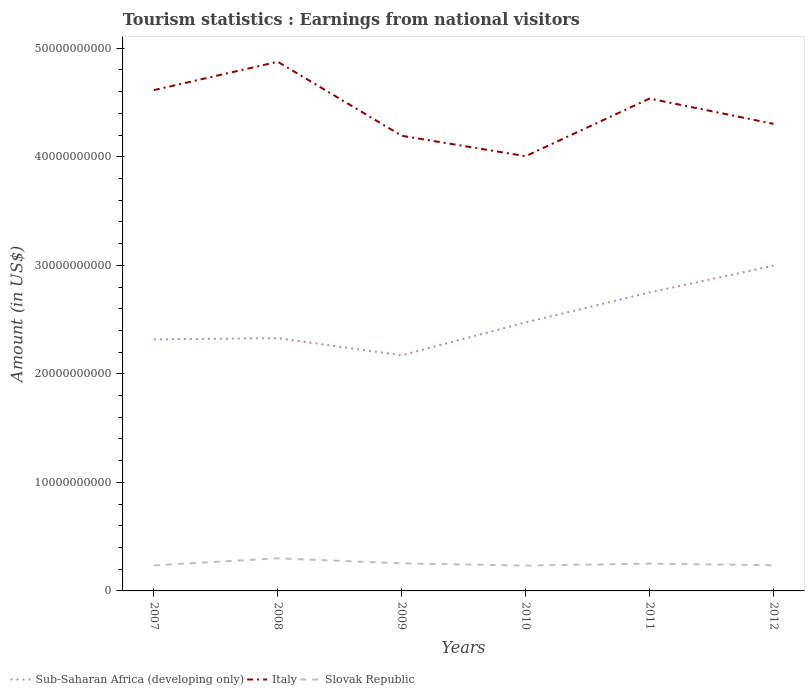Across all years, what is the maximum earnings from national visitors in Sub-Saharan Africa (developing only)?
Make the answer very short. 2.17e+1. What is the total earnings from national visitors in Italy in the graph?
Your response must be concise. -5.31e+09. What is the difference between the highest and the second highest earnings from national visitors in Italy?
Make the answer very short. 8.70e+09. How many lines are there?
Provide a succinct answer. 3. What is the difference between two consecutive major ticks on the Y-axis?
Ensure brevity in your answer.  1.00e+1. Does the graph contain grids?
Your answer should be compact. No. What is the title of the graph?
Your response must be concise. Tourism statistics : Earnings from national visitors. What is the label or title of the X-axis?
Keep it short and to the point. Years. What is the label or title of the Y-axis?
Your answer should be very brief. Amount (in US$). What is the Amount (in US$) in Sub-Saharan Africa (developing only) in 2007?
Make the answer very short. 2.32e+1. What is the Amount (in US$) of Italy in 2007?
Your response must be concise. 4.61e+1. What is the Amount (in US$) in Slovak Republic in 2007?
Offer a terse response. 2.35e+09. What is the Amount (in US$) of Sub-Saharan Africa (developing only) in 2008?
Make the answer very short. 2.33e+1. What is the Amount (in US$) in Italy in 2008?
Give a very brief answer. 4.88e+1. What is the Amount (in US$) of Slovak Republic in 2008?
Your response must be concise. 3.00e+09. What is the Amount (in US$) in Sub-Saharan Africa (developing only) in 2009?
Your response must be concise. 2.17e+1. What is the Amount (in US$) of Italy in 2009?
Your answer should be compact. 4.19e+1. What is the Amount (in US$) of Slovak Republic in 2009?
Keep it short and to the point. 2.54e+09. What is the Amount (in US$) of Sub-Saharan Africa (developing only) in 2010?
Offer a terse response. 2.47e+1. What is the Amount (in US$) in Italy in 2010?
Keep it short and to the point. 4.01e+1. What is the Amount (in US$) in Slovak Republic in 2010?
Provide a succinct answer. 2.34e+09. What is the Amount (in US$) in Sub-Saharan Africa (developing only) in 2011?
Provide a short and direct response. 2.75e+1. What is the Amount (in US$) of Italy in 2011?
Keep it short and to the point. 4.54e+1. What is the Amount (in US$) of Slovak Republic in 2011?
Ensure brevity in your answer.  2.51e+09. What is the Amount (in US$) in Sub-Saharan Africa (developing only) in 2012?
Your answer should be very brief. 3.00e+1. What is the Amount (in US$) of Italy in 2012?
Offer a terse response. 4.30e+1. What is the Amount (in US$) in Slovak Republic in 2012?
Provide a succinct answer. 2.36e+09. Across all years, what is the maximum Amount (in US$) in Sub-Saharan Africa (developing only)?
Offer a terse response. 3.00e+1. Across all years, what is the maximum Amount (in US$) of Italy?
Offer a very short reply. 4.88e+1. Across all years, what is the maximum Amount (in US$) in Slovak Republic?
Give a very brief answer. 3.00e+09. Across all years, what is the minimum Amount (in US$) in Sub-Saharan Africa (developing only)?
Give a very brief answer. 2.17e+1. Across all years, what is the minimum Amount (in US$) in Italy?
Offer a terse response. 4.01e+1. Across all years, what is the minimum Amount (in US$) in Slovak Republic?
Your answer should be very brief. 2.34e+09. What is the total Amount (in US$) of Sub-Saharan Africa (developing only) in the graph?
Your answer should be very brief. 1.50e+11. What is the total Amount (in US$) in Italy in the graph?
Give a very brief answer. 2.65e+11. What is the total Amount (in US$) in Slovak Republic in the graph?
Your answer should be compact. 1.51e+1. What is the difference between the Amount (in US$) of Sub-Saharan Africa (developing only) in 2007 and that in 2008?
Make the answer very short. -1.09e+08. What is the difference between the Amount (in US$) of Italy in 2007 and that in 2008?
Your answer should be compact. -2.61e+09. What is the difference between the Amount (in US$) of Slovak Republic in 2007 and that in 2008?
Make the answer very short. -6.52e+08. What is the difference between the Amount (in US$) in Sub-Saharan Africa (developing only) in 2007 and that in 2009?
Offer a terse response. 1.46e+09. What is the difference between the Amount (in US$) of Italy in 2007 and that in 2009?
Provide a succinct answer. 4.21e+09. What is the difference between the Amount (in US$) in Slovak Republic in 2007 and that in 2009?
Offer a very short reply. -1.87e+08. What is the difference between the Amount (in US$) in Sub-Saharan Africa (developing only) in 2007 and that in 2010?
Offer a very short reply. -1.56e+09. What is the difference between the Amount (in US$) of Italy in 2007 and that in 2010?
Give a very brief answer. 6.09e+09. What is the difference between the Amount (in US$) in Slovak Republic in 2007 and that in 2010?
Make the answer very short. 1.70e+07. What is the difference between the Amount (in US$) of Sub-Saharan Africa (developing only) in 2007 and that in 2011?
Keep it short and to the point. -4.32e+09. What is the difference between the Amount (in US$) in Italy in 2007 and that in 2011?
Provide a succinct answer. 7.76e+08. What is the difference between the Amount (in US$) in Slovak Republic in 2007 and that in 2011?
Give a very brief answer. -1.62e+08. What is the difference between the Amount (in US$) of Sub-Saharan Africa (developing only) in 2007 and that in 2012?
Offer a very short reply. -6.78e+09. What is the difference between the Amount (in US$) of Italy in 2007 and that in 2012?
Give a very brief answer. 3.11e+09. What is the difference between the Amount (in US$) of Slovak Republic in 2007 and that in 2012?
Make the answer very short. -1.30e+07. What is the difference between the Amount (in US$) of Sub-Saharan Africa (developing only) in 2008 and that in 2009?
Your answer should be very brief. 1.57e+09. What is the difference between the Amount (in US$) of Italy in 2008 and that in 2009?
Offer a very short reply. 6.82e+09. What is the difference between the Amount (in US$) of Slovak Republic in 2008 and that in 2009?
Offer a very short reply. 4.65e+08. What is the difference between the Amount (in US$) of Sub-Saharan Africa (developing only) in 2008 and that in 2010?
Provide a short and direct response. -1.45e+09. What is the difference between the Amount (in US$) in Italy in 2008 and that in 2010?
Your answer should be very brief. 8.70e+09. What is the difference between the Amount (in US$) in Slovak Republic in 2008 and that in 2010?
Offer a terse response. 6.69e+08. What is the difference between the Amount (in US$) in Sub-Saharan Africa (developing only) in 2008 and that in 2011?
Give a very brief answer. -4.21e+09. What is the difference between the Amount (in US$) in Italy in 2008 and that in 2011?
Provide a succinct answer. 3.39e+09. What is the difference between the Amount (in US$) of Slovak Republic in 2008 and that in 2011?
Offer a very short reply. 4.90e+08. What is the difference between the Amount (in US$) in Sub-Saharan Africa (developing only) in 2008 and that in 2012?
Your response must be concise. -6.67e+09. What is the difference between the Amount (in US$) of Italy in 2008 and that in 2012?
Provide a succinct answer. 5.72e+09. What is the difference between the Amount (in US$) of Slovak Republic in 2008 and that in 2012?
Provide a succinct answer. 6.39e+08. What is the difference between the Amount (in US$) of Sub-Saharan Africa (developing only) in 2009 and that in 2010?
Give a very brief answer. -3.03e+09. What is the difference between the Amount (in US$) in Italy in 2009 and that in 2010?
Keep it short and to the point. 1.88e+09. What is the difference between the Amount (in US$) of Slovak Republic in 2009 and that in 2010?
Make the answer very short. 2.04e+08. What is the difference between the Amount (in US$) in Sub-Saharan Africa (developing only) in 2009 and that in 2011?
Keep it short and to the point. -5.79e+09. What is the difference between the Amount (in US$) in Italy in 2009 and that in 2011?
Your answer should be compact. -3.43e+09. What is the difference between the Amount (in US$) of Slovak Republic in 2009 and that in 2011?
Make the answer very short. 2.50e+07. What is the difference between the Amount (in US$) of Sub-Saharan Africa (developing only) in 2009 and that in 2012?
Provide a succinct answer. -8.25e+09. What is the difference between the Amount (in US$) of Italy in 2009 and that in 2012?
Your answer should be very brief. -1.10e+09. What is the difference between the Amount (in US$) of Slovak Republic in 2009 and that in 2012?
Provide a short and direct response. 1.74e+08. What is the difference between the Amount (in US$) of Sub-Saharan Africa (developing only) in 2010 and that in 2011?
Your answer should be compact. -2.76e+09. What is the difference between the Amount (in US$) in Italy in 2010 and that in 2011?
Provide a short and direct response. -5.31e+09. What is the difference between the Amount (in US$) of Slovak Republic in 2010 and that in 2011?
Your answer should be very brief. -1.79e+08. What is the difference between the Amount (in US$) in Sub-Saharan Africa (developing only) in 2010 and that in 2012?
Offer a very short reply. -5.22e+09. What is the difference between the Amount (in US$) of Italy in 2010 and that in 2012?
Ensure brevity in your answer.  -2.98e+09. What is the difference between the Amount (in US$) in Slovak Republic in 2010 and that in 2012?
Provide a succinct answer. -3.00e+07. What is the difference between the Amount (in US$) in Sub-Saharan Africa (developing only) in 2011 and that in 2012?
Offer a very short reply. -2.46e+09. What is the difference between the Amount (in US$) of Italy in 2011 and that in 2012?
Offer a terse response. 2.33e+09. What is the difference between the Amount (in US$) in Slovak Republic in 2011 and that in 2012?
Give a very brief answer. 1.49e+08. What is the difference between the Amount (in US$) in Sub-Saharan Africa (developing only) in 2007 and the Amount (in US$) in Italy in 2008?
Keep it short and to the point. -2.56e+1. What is the difference between the Amount (in US$) in Sub-Saharan Africa (developing only) in 2007 and the Amount (in US$) in Slovak Republic in 2008?
Your answer should be very brief. 2.02e+1. What is the difference between the Amount (in US$) of Italy in 2007 and the Amount (in US$) of Slovak Republic in 2008?
Your response must be concise. 4.31e+1. What is the difference between the Amount (in US$) in Sub-Saharan Africa (developing only) in 2007 and the Amount (in US$) in Italy in 2009?
Your answer should be very brief. -1.88e+1. What is the difference between the Amount (in US$) of Sub-Saharan Africa (developing only) in 2007 and the Amount (in US$) of Slovak Republic in 2009?
Your answer should be very brief. 2.06e+1. What is the difference between the Amount (in US$) of Italy in 2007 and the Amount (in US$) of Slovak Republic in 2009?
Ensure brevity in your answer.  4.36e+1. What is the difference between the Amount (in US$) of Sub-Saharan Africa (developing only) in 2007 and the Amount (in US$) of Italy in 2010?
Your response must be concise. -1.69e+1. What is the difference between the Amount (in US$) of Sub-Saharan Africa (developing only) in 2007 and the Amount (in US$) of Slovak Republic in 2010?
Your answer should be compact. 2.08e+1. What is the difference between the Amount (in US$) in Italy in 2007 and the Amount (in US$) in Slovak Republic in 2010?
Provide a short and direct response. 4.38e+1. What is the difference between the Amount (in US$) of Sub-Saharan Africa (developing only) in 2007 and the Amount (in US$) of Italy in 2011?
Ensure brevity in your answer.  -2.22e+1. What is the difference between the Amount (in US$) in Sub-Saharan Africa (developing only) in 2007 and the Amount (in US$) in Slovak Republic in 2011?
Offer a very short reply. 2.07e+1. What is the difference between the Amount (in US$) of Italy in 2007 and the Amount (in US$) of Slovak Republic in 2011?
Ensure brevity in your answer.  4.36e+1. What is the difference between the Amount (in US$) of Sub-Saharan Africa (developing only) in 2007 and the Amount (in US$) of Italy in 2012?
Keep it short and to the point. -1.99e+1. What is the difference between the Amount (in US$) of Sub-Saharan Africa (developing only) in 2007 and the Amount (in US$) of Slovak Republic in 2012?
Your answer should be very brief. 2.08e+1. What is the difference between the Amount (in US$) of Italy in 2007 and the Amount (in US$) of Slovak Republic in 2012?
Provide a succinct answer. 4.38e+1. What is the difference between the Amount (in US$) in Sub-Saharan Africa (developing only) in 2008 and the Amount (in US$) in Italy in 2009?
Make the answer very short. -1.87e+1. What is the difference between the Amount (in US$) of Sub-Saharan Africa (developing only) in 2008 and the Amount (in US$) of Slovak Republic in 2009?
Give a very brief answer. 2.07e+1. What is the difference between the Amount (in US$) in Italy in 2008 and the Amount (in US$) in Slovak Republic in 2009?
Your answer should be very brief. 4.62e+1. What is the difference between the Amount (in US$) of Sub-Saharan Africa (developing only) in 2008 and the Amount (in US$) of Italy in 2010?
Ensure brevity in your answer.  -1.68e+1. What is the difference between the Amount (in US$) in Sub-Saharan Africa (developing only) in 2008 and the Amount (in US$) in Slovak Republic in 2010?
Make the answer very short. 2.10e+1. What is the difference between the Amount (in US$) in Italy in 2008 and the Amount (in US$) in Slovak Republic in 2010?
Offer a terse response. 4.64e+1. What is the difference between the Amount (in US$) of Sub-Saharan Africa (developing only) in 2008 and the Amount (in US$) of Italy in 2011?
Keep it short and to the point. -2.21e+1. What is the difference between the Amount (in US$) of Sub-Saharan Africa (developing only) in 2008 and the Amount (in US$) of Slovak Republic in 2011?
Provide a succinct answer. 2.08e+1. What is the difference between the Amount (in US$) of Italy in 2008 and the Amount (in US$) of Slovak Republic in 2011?
Provide a succinct answer. 4.62e+1. What is the difference between the Amount (in US$) of Sub-Saharan Africa (developing only) in 2008 and the Amount (in US$) of Italy in 2012?
Offer a very short reply. -1.97e+1. What is the difference between the Amount (in US$) in Sub-Saharan Africa (developing only) in 2008 and the Amount (in US$) in Slovak Republic in 2012?
Your answer should be very brief. 2.09e+1. What is the difference between the Amount (in US$) in Italy in 2008 and the Amount (in US$) in Slovak Republic in 2012?
Your answer should be compact. 4.64e+1. What is the difference between the Amount (in US$) of Sub-Saharan Africa (developing only) in 2009 and the Amount (in US$) of Italy in 2010?
Give a very brief answer. -1.83e+1. What is the difference between the Amount (in US$) of Sub-Saharan Africa (developing only) in 2009 and the Amount (in US$) of Slovak Republic in 2010?
Give a very brief answer. 1.94e+1. What is the difference between the Amount (in US$) in Italy in 2009 and the Amount (in US$) in Slovak Republic in 2010?
Give a very brief answer. 3.96e+1. What is the difference between the Amount (in US$) of Sub-Saharan Africa (developing only) in 2009 and the Amount (in US$) of Italy in 2011?
Make the answer very short. -2.37e+1. What is the difference between the Amount (in US$) of Sub-Saharan Africa (developing only) in 2009 and the Amount (in US$) of Slovak Republic in 2011?
Your response must be concise. 1.92e+1. What is the difference between the Amount (in US$) in Italy in 2009 and the Amount (in US$) in Slovak Republic in 2011?
Your answer should be very brief. 3.94e+1. What is the difference between the Amount (in US$) of Sub-Saharan Africa (developing only) in 2009 and the Amount (in US$) of Italy in 2012?
Provide a succinct answer. -2.13e+1. What is the difference between the Amount (in US$) in Sub-Saharan Africa (developing only) in 2009 and the Amount (in US$) in Slovak Republic in 2012?
Make the answer very short. 1.93e+1. What is the difference between the Amount (in US$) of Italy in 2009 and the Amount (in US$) of Slovak Republic in 2012?
Offer a very short reply. 3.96e+1. What is the difference between the Amount (in US$) of Sub-Saharan Africa (developing only) in 2010 and the Amount (in US$) of Italy in 2011?
Offer a very short reply. -2.06e+1. What is the difference between the Amount (in US$) of Sub-Saharan Africa (developing only) in 2010 and the Amount (in US$) of Slovak Republic in 2011?
Offer a terse response. 2.22e+1. What is the difference between the Amount (in US$) of Italy in 2010 and the Amount (in US$) of Slovak Republic in 2011?
Make the answer very short. 3.75e+1. What is the difference between the Amount (in US$) in Sub-Saharan Africa (developing only) in 2010 and the Amount (in US$) in Italy in 2012?
Provide a succinct answer. -1.83e+1. What is the difference between the Amount (in US$) of Sub-Saharan Africa (developing only) in 2010 and the Amount (in US$) of Slovak Republic in 2012?
Your response must be concise. 2.24e+1. What is the difference between the Amount (in US$) of Italy in 2010 and the Amount (in US$) of Slovak Republic in 2012?
Your answer should be very brief. 3.77e+1. What is the difference between the Amount (in US$) of Sub-Saharan Africa (developing only) in 2011 and the Amount (in US$) of Italy in 2012?
Offer a terse response. -1.55e+1. What is the difference between the Amount (in US$) in Sub-Saharan Africa (developing only) in 2011 and the Amount (in US$) in Slovak Republic in 2012?
Make the answer very short. 2.51e+1. What is the difference between the Amount (in US$) of Italy in 2011 and the Amount (in US$) of Slovak Republic in 2012?
Your answer should be very brief. 4.30e+1. What is the average Amount (in US$) in Sub-Saharan Africa (developing only) per year?
Offer a terse response. 2.51e+1. What is the average Amount (in US$) of Italy per year?
Your response must be concise. 4.42e+1. What is the average Amount (in US$) of Slovak Republic per year?
Offer a terse response. 2.52e+09. In the year 2007, what is the difference between the Amount (in US$) of Sub-Saharan Africa (developing only) and Amount (in US$) of Italy?
Keep it short and to the point. -2.30e+1. In the year 2007, what is the difference between the Amount (in US$) of Sub-Saharan Africa (developing only) and Amount (in US$) of Slovak Republic?
Your answer should be compact. 2.08e+1. In the year 2007, what is the difference between the Amount (in US$) of Italy and Amount (in US$) of Slovak Republic?
Make the answer very short. 4.38e+1. In the year 2008, what is the difference between the Amount (in US$) of Sub-Saharan Africa (developing only) and Amount (in US$) of Italy?
Offer a terse response. -2.55e+1. In the year 2008, what is the difference between the Amount (in US$) of Sub-Saharan Africa (developing only) and Amount (in US$) of Slovak Republic?
Keep it short and to the point. 2.03e+1. In the year 2008, what is the difference between the Amount (in US$) in Italy and Amount (in US$) in Slovak Republic?
Keep it short and to the point. 4.58e+1. In the year 2009, what is the difference between the Amount (in US$) in Sub-Saharan Africa (developing only) and Amount (in US$) in Italy?
Keep it short and to the point. -2.02e+1. In the year 2009, what is the difference between the Amount (in US$) of Sub-Saharan Africa (developing only) and Amount (in US$) of Slovak Republic?
Ensure brevity in your answer.  1.92e+1. In the year 2009, what is the difference between the Amount (in US$) in Italy and Amount (in US$) in Slovak Republic?
Your answer should be compact. 3.94e+1. In the year 2010, what is the difference between the Amount (in US$) in Sub-Saharan Africa (developing only) and Amount (in US$) in Italy?
Offer a very short reply. -1.53e+1. In the year 2010, what is the difference between the Amount (in US$) in Sub-Saharan Africa (developing only) and Amount (in US$) in Slovak Republic?
Keep it short and to the point. 2.24e+1. In the year 2010, what is the difference between the Amount (in US$) in Italy and Amount (in US$) in Slovak Republic?
Offer a terse response. 3.77e+1. In the year 2011, what is the difference between the Amount (in US$) in Sub-Saharan Africa (developing only) and Amount (in US$) in Italy?
Your response must be concise. -1.79e+1. In the year 2011, what is the difference between the Amount (in US$) in Sub-Saharan Africa (developing only) and Amount (in US$) in Slovak Republic?
Provide a short and direct response. 2.50e+1. In the year 2011, what is the difference between the Amount (in US$) of Italy and Amount (in US$) of Slovak Republic?
Your response must be concise. 4.29e+1. In the year 2012, what is the difference between the Amount (in US$) of Sub-Saharan Africa (developing only) and Amount (in US$) of Italy?
Your response must be concise. -1.31e+1. In the year 2012, what is the difference between the Amount (in US$) in Sub-Saharan Africa (developing only) and Amount (in US$) in Slovak Republic?
Keep it short and to the point. 2.76e+1. In the year 2012, what is the difference between the Amount (in US$) of Italy and Amount (in US$) of Slovak Republic?
Offer a very short reply. 4.07e+1. What is the ratio of the Amount (in US$) of Italy in 2007 to that in 2008?
Your answer should be compact. 0.95. What is the ratio of the Amount (in US$) of Slovak Republic in 2007 to that in 2008?
Your response must be concise. 0.78. What is the ratio of the Amount (in US$) of Sub-Saharan Africa (developing only) in 2007 to that in 2009?
Offer a terse response. 1.07. What is the ratio of the Amount (in US$) in Italy in 2007 to that in 2009?
Provide a succinct answer. 1.1. What is the ratio of the Amount (in US$) of Slovak Republic in 2007 to that in 2009?
Your answer should be compact. 0.93. What is the ratio of the Amount (in US$) of Sub-Saharan Africa (developing only) in 2007 to that in 2010?
Your answer should be compact. 0.94. What is the ratio of the Amount (in US$) of Italy in 2007 to that in 2010?
Provide a succinct answer. 1.15. What is the ratio of the Amount (in US$) in Slovak Republic in 2007 to that in 2010?
Your answer should be very brief. 1.01. What is the ratio of the Amount (in US$) of Sub-Saharan Africa (developing only) in 2007 to that in 2011?
Ensure brevity in your answer.  0.84. What is the ratio of the Amount (in US$) of Italy in 2007 to that in 2011?
Provide a short and direct response. 1.02. What is the ratio of the Amount (in US$) in Slovak Republic in 2007 to that in 2011?
Make the answer very short. 0.94. What is the ratio of the Amount (in US$) of Sub-Saharan Africa (developing only) in 2007 to that in 2012?
Provide a succinct answer. 0.77. What is the ratio of the Amount (in US$) of Italy in 2007 to that in 2012?
Offer a very short reply. 1.07. What is the ratio of the Amount (in US$) in Sub-Saharan Africa (developing only) in 2008 to that in 2009?
Make the answer very short. 1.07. What is the ratio of the Amount (in US$) of Italy in 2008 to that in 2009?
Ensure brevity in your answer.  1.16. What is the ratio of the Amount (in US$) of Slovak Republic in 2008 to that in 2009?
Offer a very short reply. 1.18. What is the ratio of the Amount (in US$) of Sub-Saharan Africa (developing only) in 2008 to that in 2010?
Offer a very short reply. 0.94. What is the ratio of the Amount (in US$) in Italy in 2008 to that in 2010?
Make the answer very short. 1.22. What is the ratio of the Amount (in US$) of Slovak Republic in 2008 to that in 2010?
Your response must be concise. 1.29. What is the ratio of the Amount (in US$) in Sub-Saharan Africa (developing only) in 2008 to that in 2011?
Your answer should be compact. 0.85. What is the ratio of the Amount (in US$) of Italy in 2008 to that in 2011?
Give a very brief answer. 1.07. What is the ratio of the Amount (in US$) of Slovak Republic in 2008 to that in 2011?
Ensure brevity in your answer.  1.19. What is the ratio of the Amount (in US$) in Sub-Saharan Africa (developing only) in 2008 to that in 2012?
Give a very brief answer. 0.78. What is the ratio of the Amount (in US$) in Italy in 2008 to that in 2012?
Provide a short and direct response. 1.13. What is the ratio of the Amount (in US$) of Slovak Republic in 2008 to that in 2012?
Make the answer very short. 1.27. What is the ratio of the Amount (in US$) of Sub-Saharan Africa (developing only) in 2009 to that in 2010?
Make the answer very short. 0.88. What is the ratio of the Amount (in US$) in Italy in 2009 to that in 2010?
Your response must be concise. 1.05. What is the ratio of the Amount (in US$) of Slovak Republic in 2009 to that in 2010?
Give a very brief answer. 1.09. What is the ratio of the Amount (in US$) of Sub-Saharan Africa (developing only) in 2009 to that in 2011?
Offer a very short reply. 0.79. What is the ratio of the Amount (in US$) of Italy in 2009 to that in 2011?
Offer a terse response. 0.92. What is the ratio of the Amount (in US$) in Slovak Republic in 2009 to that in 2011?
Make the answer very short. 1.01. What is the ratio of the Amount (in US$) of Sub-Saharan Africa (developing only) in 2009 to that in 2012?
Offer a very short reply. 0.72. What is the ratio of the Amount (in US$) of Italy in 2009 to that in 2012?
Keep it short and to the point. 0.97. What is the ratio of the Amount (in US$) of Slovak Republic in 2009 to that in 2012?
Make the answer very short. 1.07. What is the ratio of the Amount (in US$) of Sub-Saharan Africa (developing only) in 2010 to that in 2011?
Provide a short and direct response. 0.9. What is the ratio of the Amount (in US$) of Italy in 2010 to that in 2011?
Make the answer very short. 0.88. What is the ratio of the Amount (in US$) in Slovak Republic in 2010 to that in 2011?
Provide a short and direct response. 0.93. What is the ratio of the Amount (in US$) in Sub-Saharan Africa (developing only) in 2010 to that in 2012?
Offer a very short reply. 0.83. What is the ratio of the Amount (in US$) in Italy in 2010 to that in 2012?
Provide a short and direct response. 0.93. What is the ratio of the Amount (in US$) in Slovak Republic in 2010 to that in 2012?
Make the answer very short. 0.99. What is the ratio of the Amount (in US$) of Sub-Saharan Africa (developing only) in 2011 to that in 2012?
Offer a terse response. 0.92. What is the ratio of the Amount (in US$) of Italy in 2011 to that in 2012?
Provide a short and direct response. 1.05. What is the ratio of the Amount (in US$) of Slovak Republic in 2011 to that in 2012?
Provide a succinct answer. 1.06. What is the difference between the highest and the second highest Amount (in US$) of Sub-Saharan Africa (developing only)?
Your answer should be compact. 2.46e+09. What is the difference between the highest and the second highest Amount (in US$) of Italy?
Keep it short and to the point. 2.61e+09. What is the difference between the highest and the second highest Amount (in US$) of Slovak Republic?
Make the answer very short. 4.65e+08. What is the difference between the highest and the lowest Amount (in US$) of Sub-Saharan Africa (developing only)?
Provide a succinct answer. 8.25e+09. What is the difference between the highest and the lowest Amount (in US$) of Italy?
Provide a short and direct response. 8.70e+09. What is the difference between the highest and the lowest Amount (in US$) of Slovak Republic?
Give a very brief answer. 6.69e+08. 